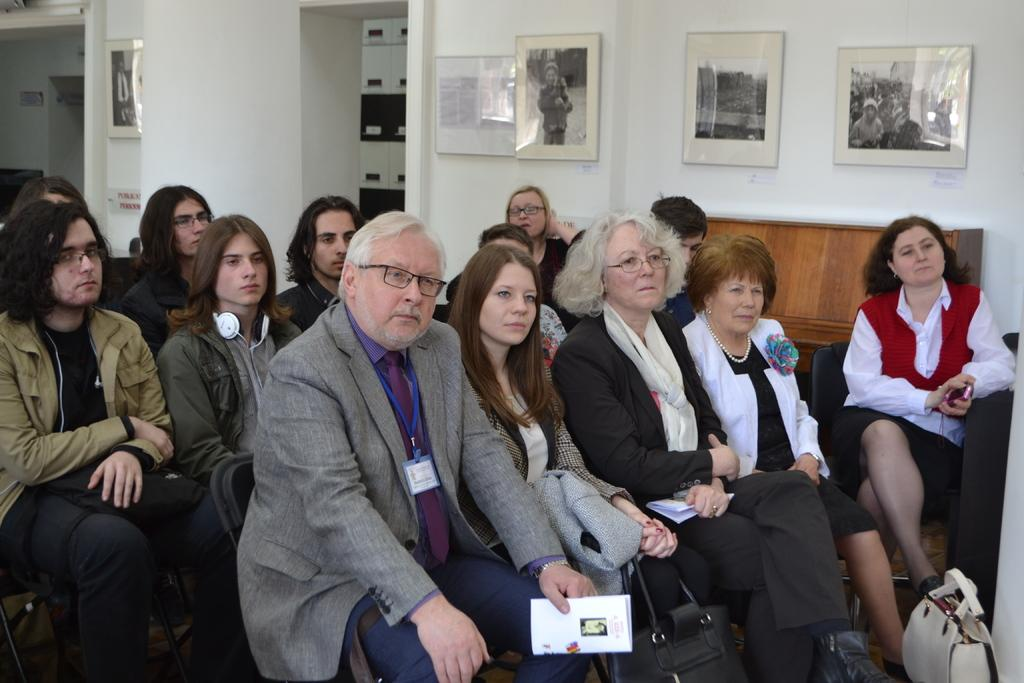What are the people in the image doing? The people in the image are sitting on chairs. What can be seen on the wall in the image? There is a wall with photo frames in the image. What type of fireman is depicted in the photo frames on the wall? There is no fireman present in the image, as the provided facts only mention people sitting on chairs and a wall with photo frames. 